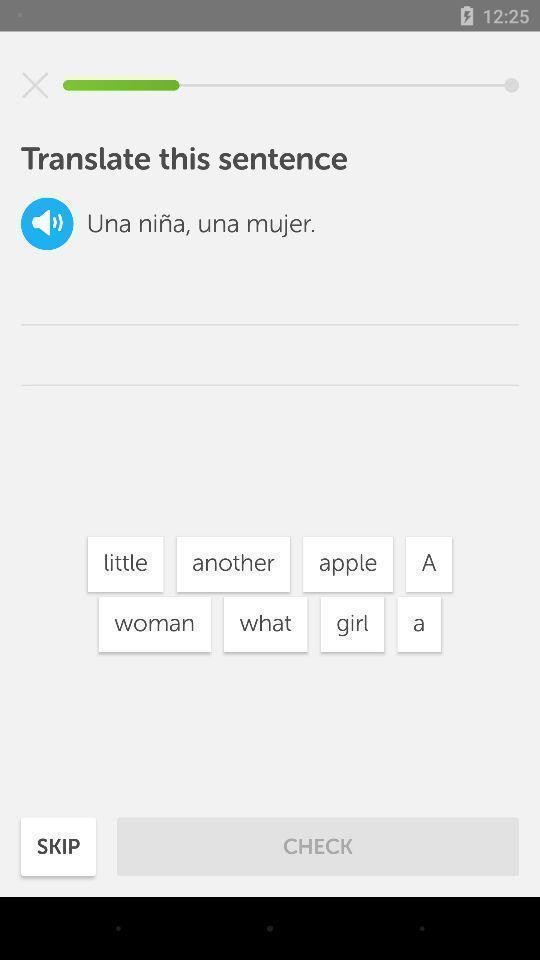What can you discern from this picture? Page showing different options for translating sentence. 